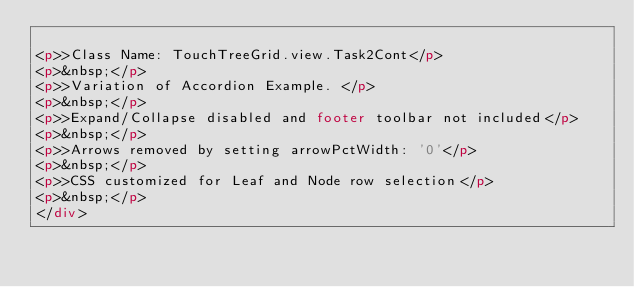Convert code to text. <code><loc_0><loc_0><loc_500><loc_500><_HTML_>
<p>>Class Name: TouchTreeGrid.view.Task2Cont</p>
<p>&nbsp;</p>
<p>>Variation of Accordion Example. </p>	
<p>&nbsp;</p>
<p>>Expand/Collapse disabled and footer toolbar not included</p>
<p>&nbsp;</p>
<p>>Arrows removed by setting arrowPctWidth: '0'</p>
<p>&nbsp;</p>
<p>>CSS customized for Leaf and Node row selection</p>
<p>&nbsp;</p>
</div>	



	
</code> 